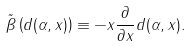<formula> <loc_0><loc_0><loc_500><loc_500>\tilde { \beta } \left ( d ( \alpha , x ) \right ) \equiv - x \frac { \partial } { \partial x } d ( \alpha , x ) .</formula> 